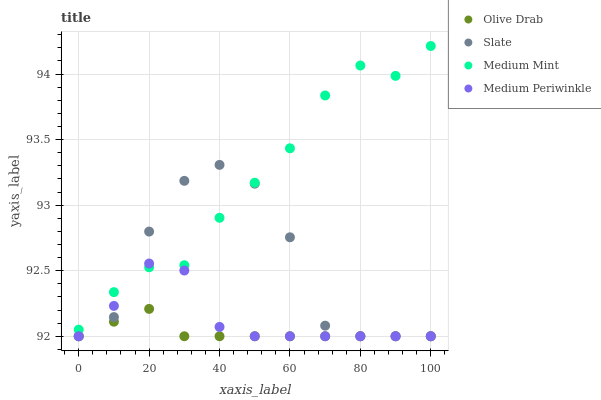Does Olive Drab have the minimum area under the curve?
Answer yes or no. Yes. Does Medium Mint have the maximum area under the curve?
Answer yes or no. Yes. Does Slate have the minimum area under the curve?
Answer yes or no. No. Does Slate have the maximum area under the curve?
Answer yes or no. No. Is Olive Drab the smoothest?
Answer yes or no. Yes. Is Slate the roughest?
Answer yes or no. Yes. Is Medium Periwinkle the smoothest?
Answer yes or no. No. Is Medium Periwinkle the roughest?
Answer yes or no. No. Does Slate have the lowest value?
Answer yes or no. Yes. Does Medium Mint have the highest value?
Answer yes or no. Yes. Does Slate have the highest value?
Answer yes or no. No. Is Olive Drab less than Medium Mint?
Answer yes or no. Yes. Is Medium Mint greater than Olive Drab?
Answer yes or no. Yes. Does Olive Drab intersect Medium Periwinkle?
Answer yes or no. Yes. Is Olive Drab less than Medium Periwinkle?
Answer yes or no. No. Is Olive Drab greater than Medium Periwinkle?
Answer yes or no. No. Does Olive Drab intersect Medium Mint?
Answer yes or no. No. 